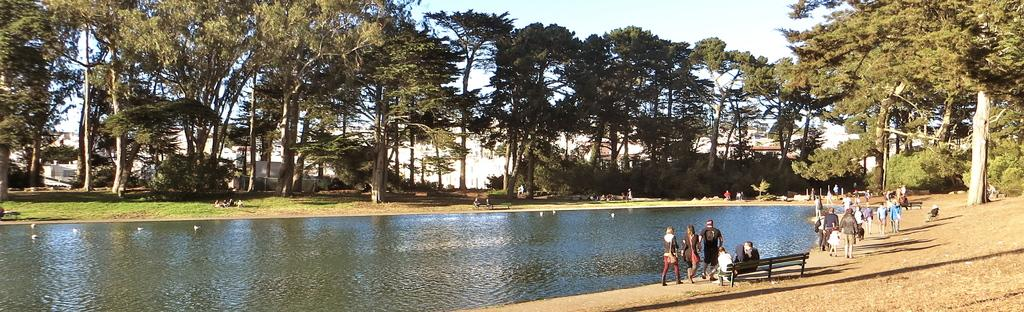What body of water is present in the image? There is a lake in the image. Where is the bench located in the image? The bench is on the right side of the image. What are the people in the image doing? People are walking on the land in the image. What can be seen in the background of the image? There are trees and the sky visible in the background of the image. What type of milk is being poured into the lake in the image? There is no milk being poured into the lake in the image. What tool is being used to tighten the curve in the image? There is no tool or curve present in the image. 